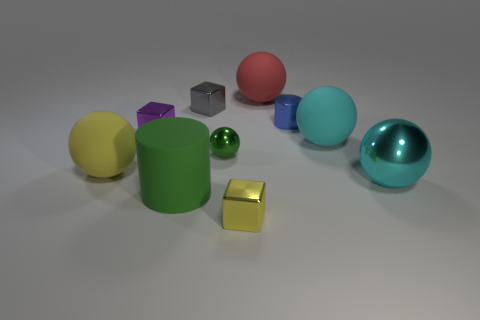There is a cylinder that is the same color as the tiny shiny sphere; what is its size?
Provide a short and direct response. Large. There is a small metal thing that is the same color as the big rubber cylinder; what is its shape?
Your response must be concise. Sphere. What number of cylinders are either small gray metallic things or cyan rubber things?
Provide a succinct answer. 0. There is a sphere that is the same size as the purple metal thing; what is its color?
Provide a succinct answer. Green. What number of small metallic things are right of the green matte cylinder and behind the yellow cube?
Offer a very short reply. 3. What is the tiny yellow object made of?
Offer a very short reply. Metal. What number of things are either red cubes or cyan things?
Provide a succinct answer. 2. There is a cyan object behind the small green object; is it the same size as the rubber sphere that is to the left of the red thing?
Make the answer very short. Yes. How many other objects are there of the same size as the green matte thing?
Make the answer very short. 4. What number of objects are big matte objects to the right of the small yellow metal thing or metallic cylinders that are behind the green metal sphere?
Keep it short and to the point. 3. 